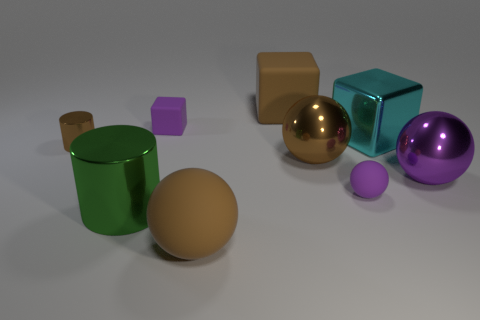Do the tiny matte sphere and the big metal block have the same color?
Your response must be concise. No. Is the number of large gray blocks less than the number of big green metallic things?
Ensure brevity in your answer.  Yes. What material is the tiny purple thing behind the small sphere?
Your answer should be very brief. Rubber. There is a brown cylinder that is the same size as the purple block; what material is it?
Your answer should be compact. Metal. The small object on the left side of the tiny purple matte thing left of the big ball that is left of the brown matte block is made of what material?
Your answer should be compact. Metal. Do the purple object behind the purple metal ball and the tiny metal cylinder have the same size?
Give a very brief answer. Yes. Is the number of big cyan cylinders greater than the number of large rubber blocks?
Offer a very short reply. No. What number of small things are cyan cubes or purple objects?
Provide a short and direct response. 2. How many other things are the same color as the large matte block?
Offer a very short reply. 3. What number of tiny red cylinders have the same material as the small brown thing?
Provide a succinct answer. 0. 